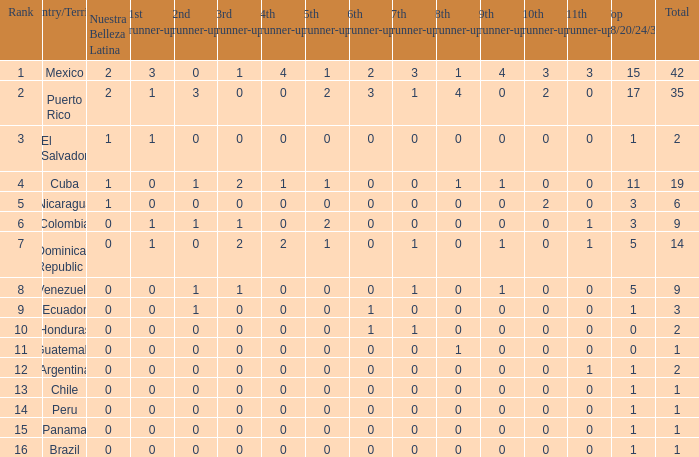Identify the 9th runner-up that has a top 18/20/24/30 score above 17 and a 5th runner-up score equal to 2. None. 